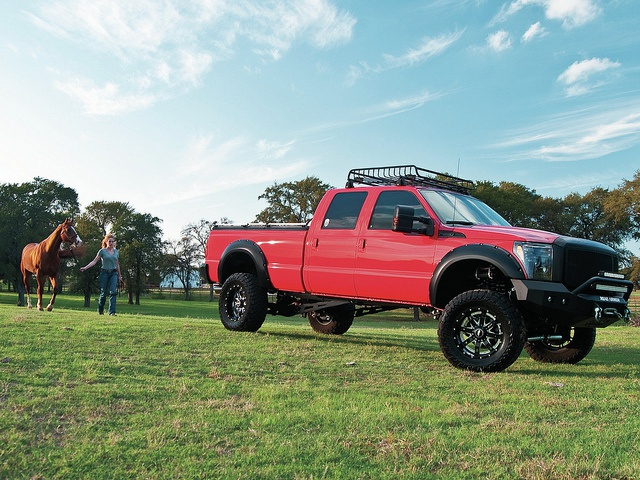Describe the objects in this image and their specific colors. I can see truck in lightblue, black, salmon, red, and gray tones, horse in lightblue, black, maroon, tan, and brown tones, and people in lightblue, black, blue, gray, and darkblue tones in this image. 